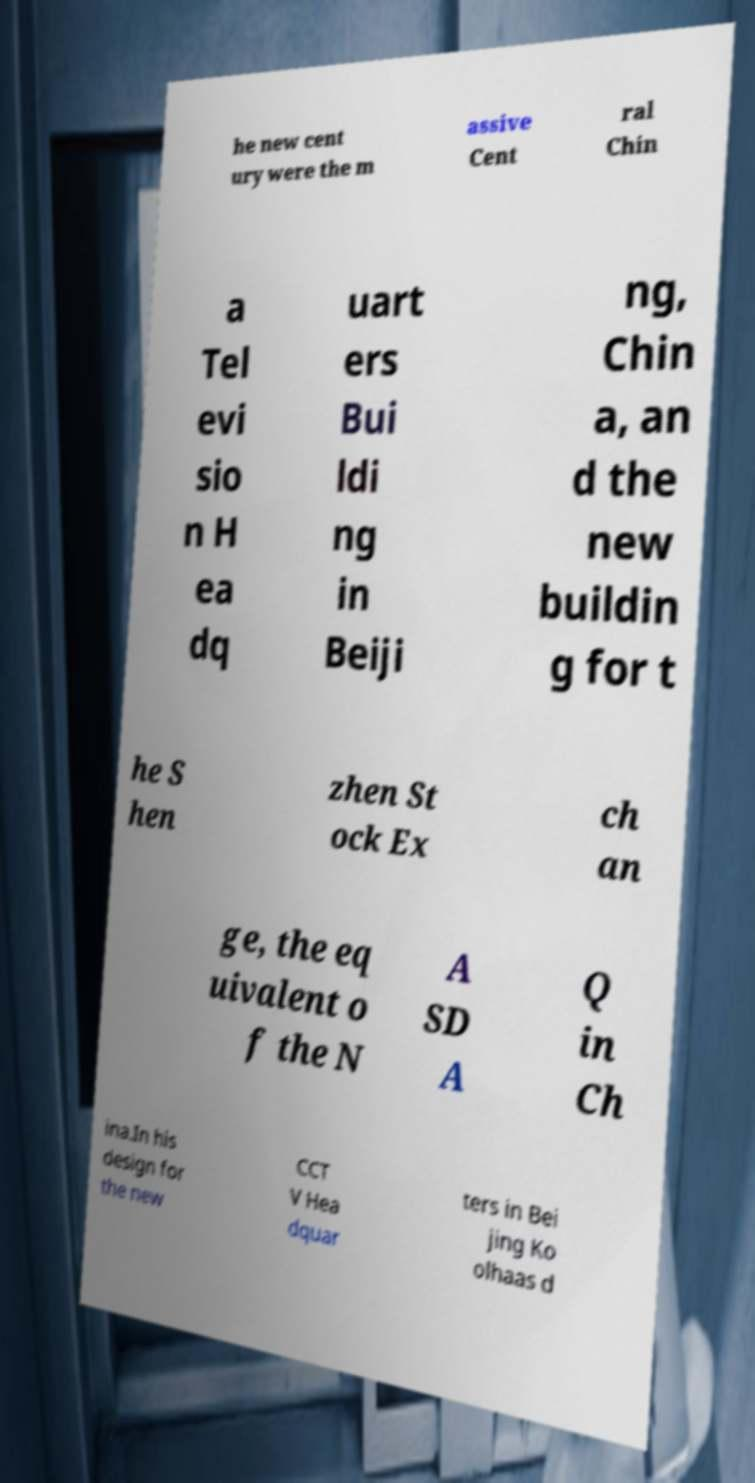For documentation purposes, I need the text within this image transcribed. Could you provide that? he new cent ury were the m assive Cent ral Chin a Tel evi sio n H ea dq uart ers Bui ldi ng in Beiji ng, Chin a, an d the new buildin g for t he S hen zhen St ock Ex ch an ge, the eq uivalent o f the N A SD A Q in Ch ina.In his design for the new CCT V Hea dquar ters in Bei jing Ko olhaas d 